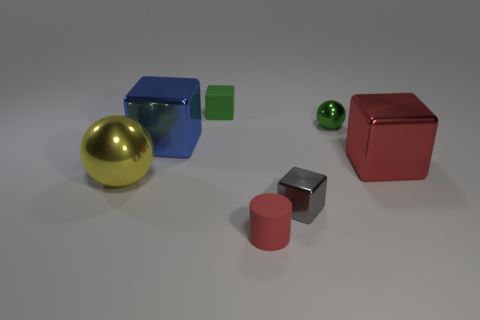What number of tiny matte objects are behind the tiny cube in front of the matte block? Behind the tiny cube, which is positioned in front of the matte block, there is one small, transparent-green marble. 